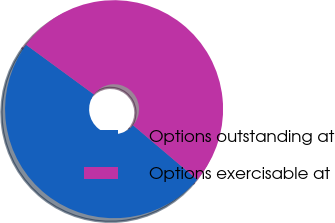Convert chart to OTSL. <chart><loc_0><loc_0><loc_500><loc_500><pie_chart><fcel>Options outstanding at<fcel>Options exercisable at<nl><fcel>48.87%<fcel>51.13%<nl></chart> 